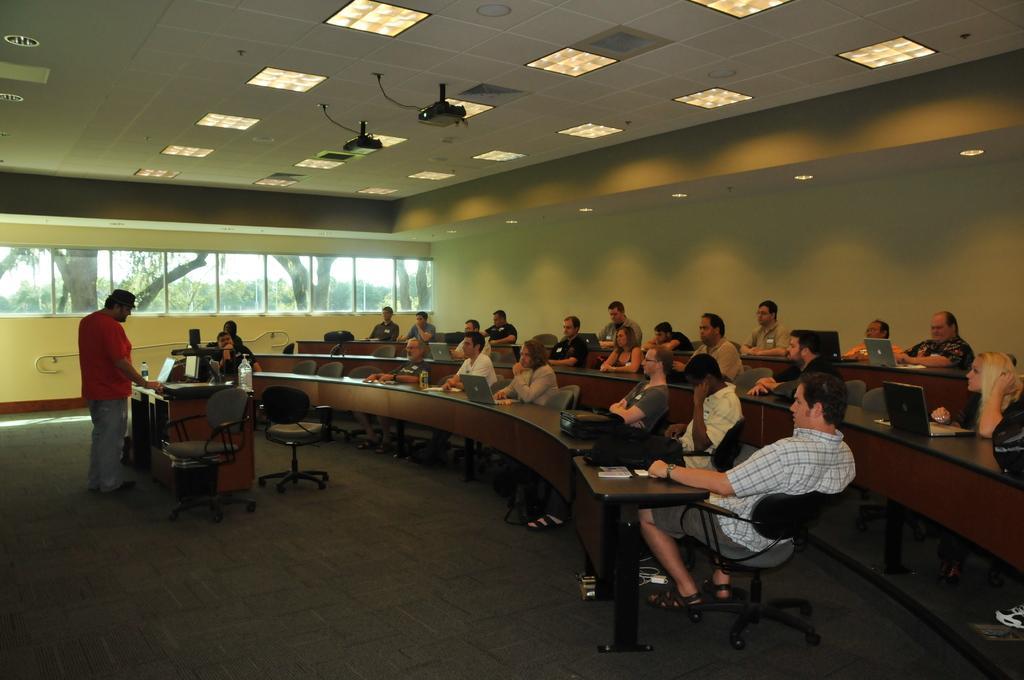In one or two sentences, can you explain what this image depicts? This is a conference hall people are sitting on the chair. On the table they are having laptops,bags,water bottle. On the left a person is standing and explaining to the people in front of him. On the roof there are lights and projectors. 